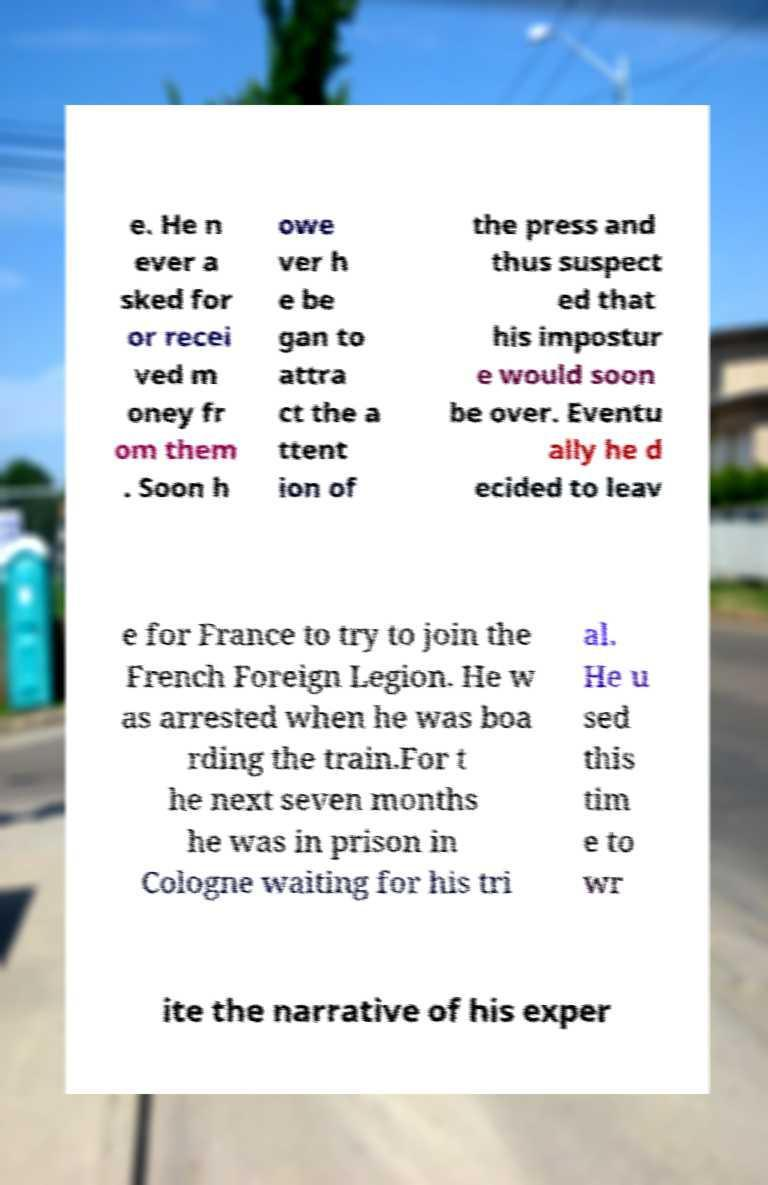For documentation purposes, I need the text within this image transcribed. Could you provide that? e. He n ever a sked for or recei ved m oney fr om them . Soon h owe ver h e be gan to attra ct the a ttent ion of the press and thus suspect ed that his impostur e would soon be over. Eventu ally he d ecided to leav e for France to try to join the French Foreign Legion. He w as arrested when he was boa rding the train.For t he next seven months he was in prison in Cologne waiting for his tri al. He u sed this tim e to wr ite the narrative of his exper 